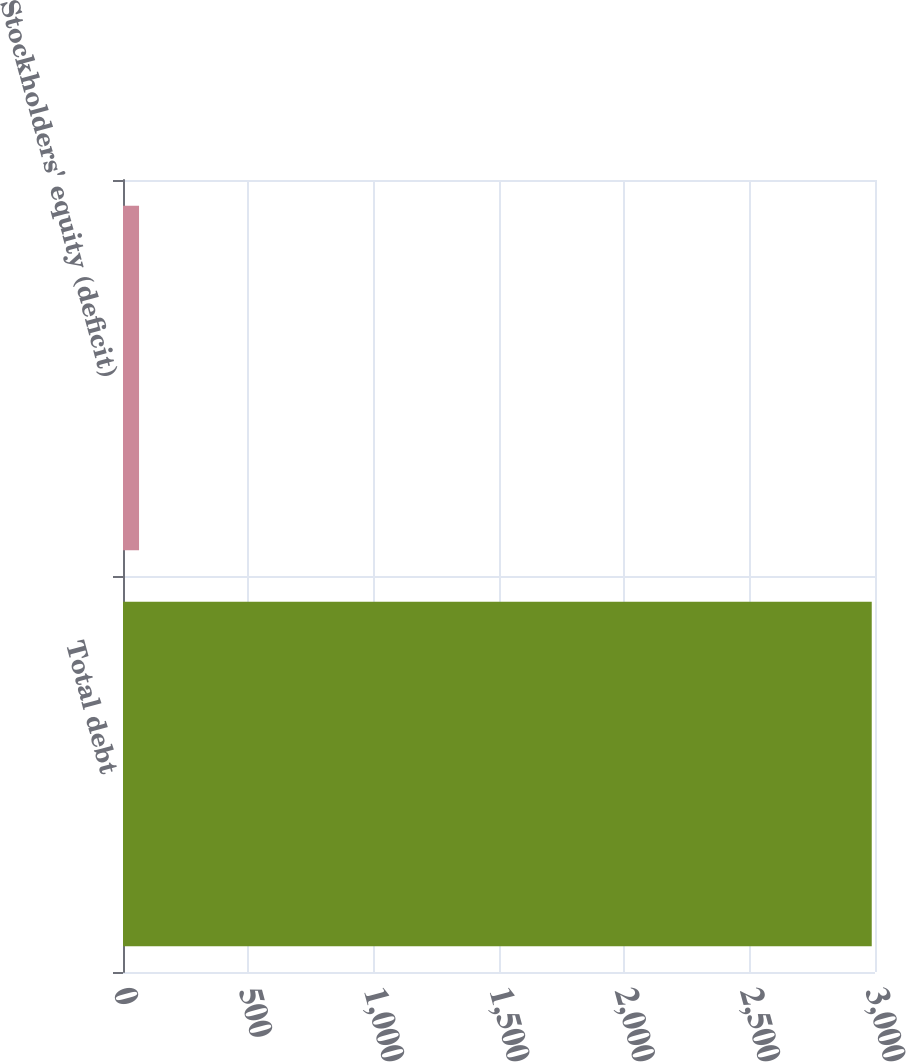Convert chart. <chart><loc_0><loc_0><loc_500><loc_500><bar_chart><fcel>Total debt<fcel>Stockholders' equity (deficit)<nl><fcel>2987<fcel>64<nl></chart> 